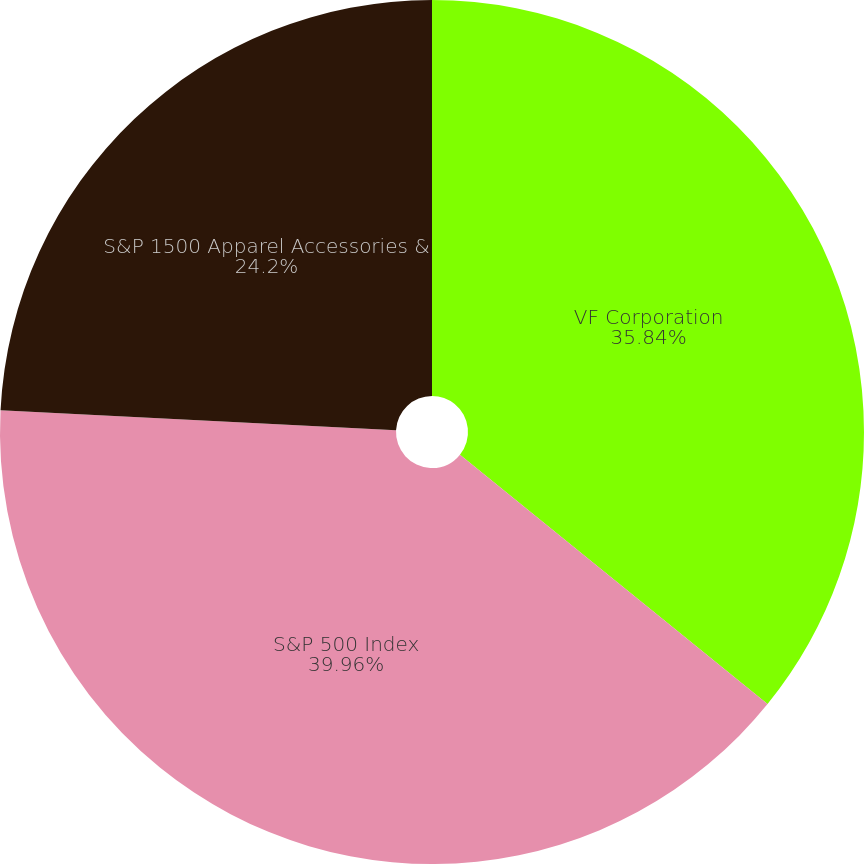Convert chart. <chart><loc_0><loc_0><loc_500><loc_500><pie_chart><fcel>VF Corporation<fcel>S&P 500 Index<fcel>S&P 1500 Apparel Accessories &<nl><fcel>35.84%<fcel>39.95%<fcel>24.2%<nl></chart> 